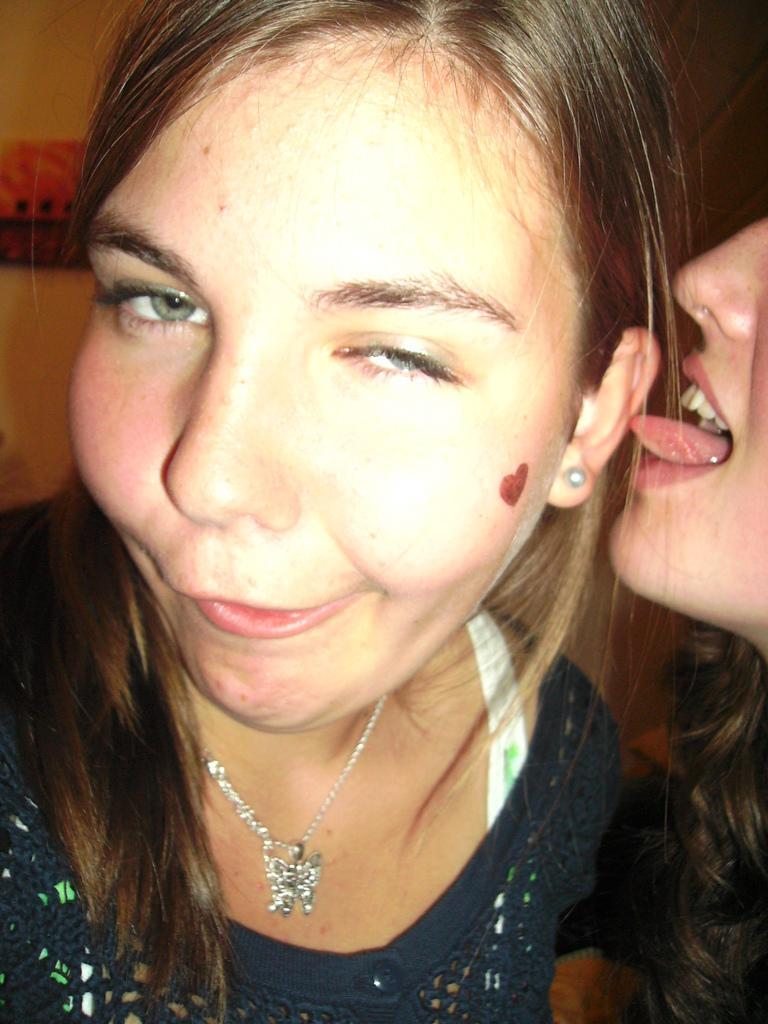In one or two sentences, can you explain what this image depicts? In this picture I can see a woman, and there is another person, and there is blur background. 